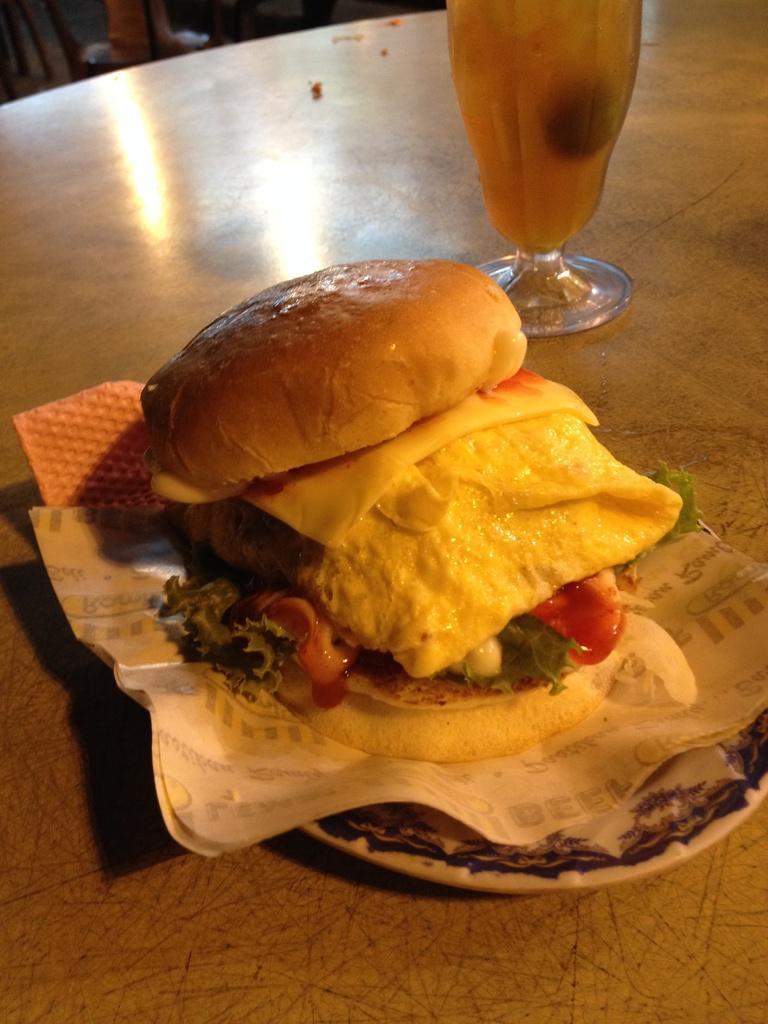Can you describe this image briefly? In this image we can see a plate containing food and a paper placed on the surface, we can also see a glass containing liquid. 